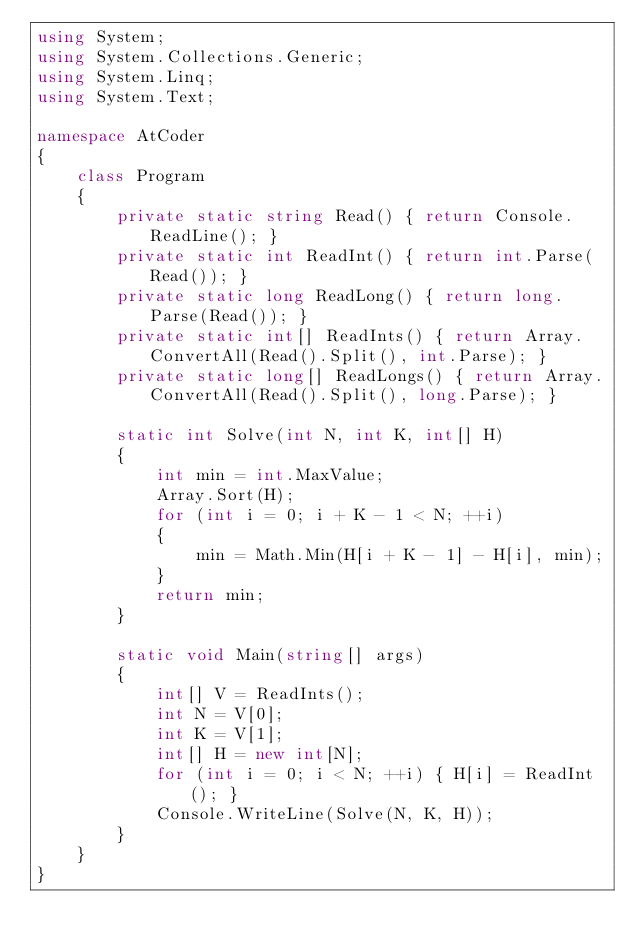Convert code to text. <code><loc_0><loc_0><loc_500><loc_500><_C#_>using System;
using System.Collections.Generic;
using System.Linq;
using System.Text;

namespace AtCoder
{
    class Program
    {
        private static string Read() { return Console.ReadLine(); }
        private static int ReadInt() { return int.Parse(Read()); }
        private static long ReadLong() { return long.Parse(Read()); }
        private static int[] ReadInts() { return Array.ConvertAll(Read().Split(), int.Parse); }
        private static long[] ReadLongs() { return Array.ConvertAll(Read().Split(), long.Parse); }

        static int Solve(int N, int K, int[] H)
        {
            int min = int.MaxValue;
            Array.Sort(H);
            for (int i = 0; i + K - 1 < N; ++i)
            {
                min = Math.Min(H[i + K - 1] - H[i], min);
            }
            return min;
        }

        static void Main(string[] args)
        {
            int[] V = ReadInts();
            int N = V[0];
            int K = V[1];
            int[] H = new int[N];
            for (int i = 0; i < N; ++i) { H[i] = ReadInt(); }
            Console.WriteLine(Solve(N, K, H));
        }
    }
}
</code> 